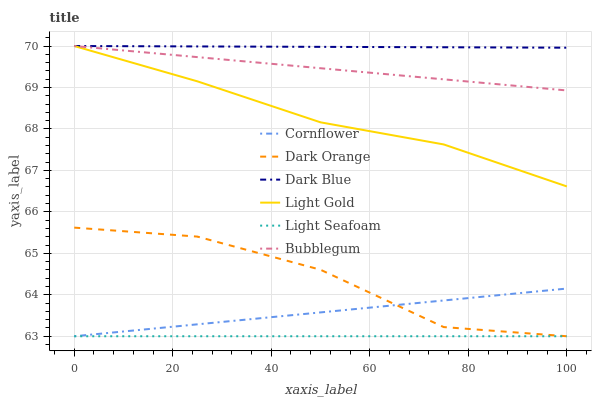Does Light Seafoam have the minimum area under the curve?
Answer yes or no. Yes. Does Dark Blue have the maximum area under the curve?
Answer yes or no. Yes. Does Dark Orange have the minimum area under the curve?
Answer yes or no. No. Does Dark Orange have the maximum area under the curve?
Answer yes or no. No. Is Cornflower the smoothest?
Answer yes or no. Yes. Is Dark Orange the roughest?
Answer yes or no. Yes. Is Dark Orange the smoothest?
Answer yes or no. No. Is Bubblegum the roughest?
Answer yes or no. No. Does Cornflower have the lowest value?
Answer yes or no. Yes. Does Bubblegum have the lowest value?
Answer yes or no. No. Does Light Gold have the highest value?
Answer yes or no. Yes. Does Dark Orange have the highest value?
Answer yes or no. No. Is Cornflower less than Dark Blue?
Answer yes or no. Yes. Is Bubblegum greater than Light Seafoam?
Answer yes or no. Yes. Does Light Seafoam intersect Dark Orange?
Answer yes or no. Yes. Is Light Seafoam less than Dark Orange?
Answer yes or no. No. Is Light Seafoam greater than Dark Orange?
Answer yes or no. No. Does Cornflower intersect Dark Blue?
Answer yes or no. No. 